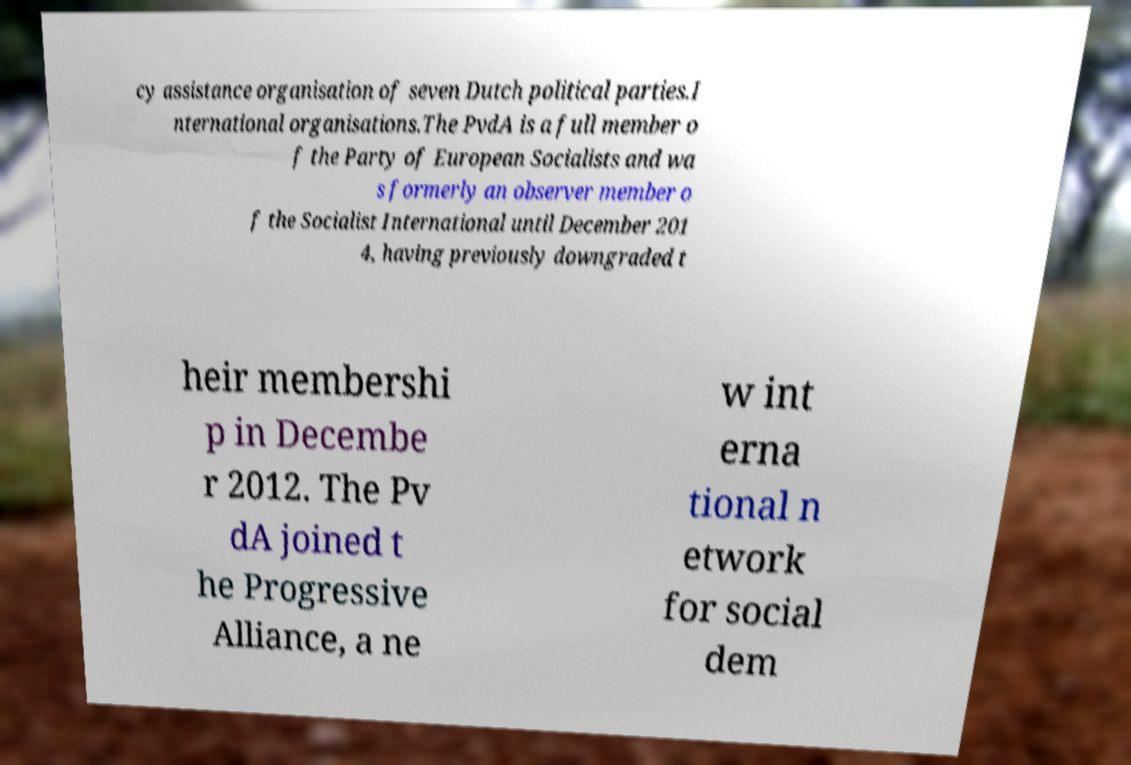Please read and relay the text visible in this image. What does it say? cy assistance organisation of seven Dutch political parties.I nternational organisations.The PvdA is a full member o f the Party of European Socialists and wa s formerly an observer member o f the Socialist International until December 201 4, having previously downgraded t heir membershi p in Decembe r 2012. The Pv dA joined t he Progressive Alliance, a ne w int erna tional n etwork for social dem 